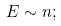Convert formula to latex. <formula><loc_0><loc_0><loc_500><loc_500>E \sim n ;</formula> 